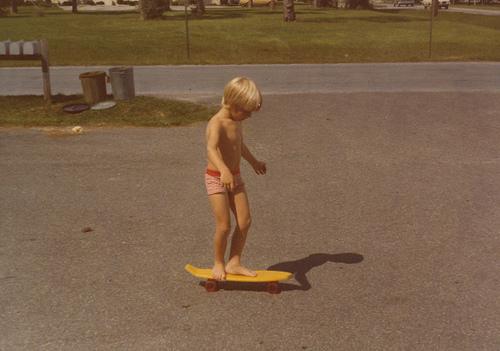What is he on?
Concise answer only. Skateboard. How many people are there?
Quick response, please. 1. Are the trashcan lids on or off?
Answer briefly. Off. 